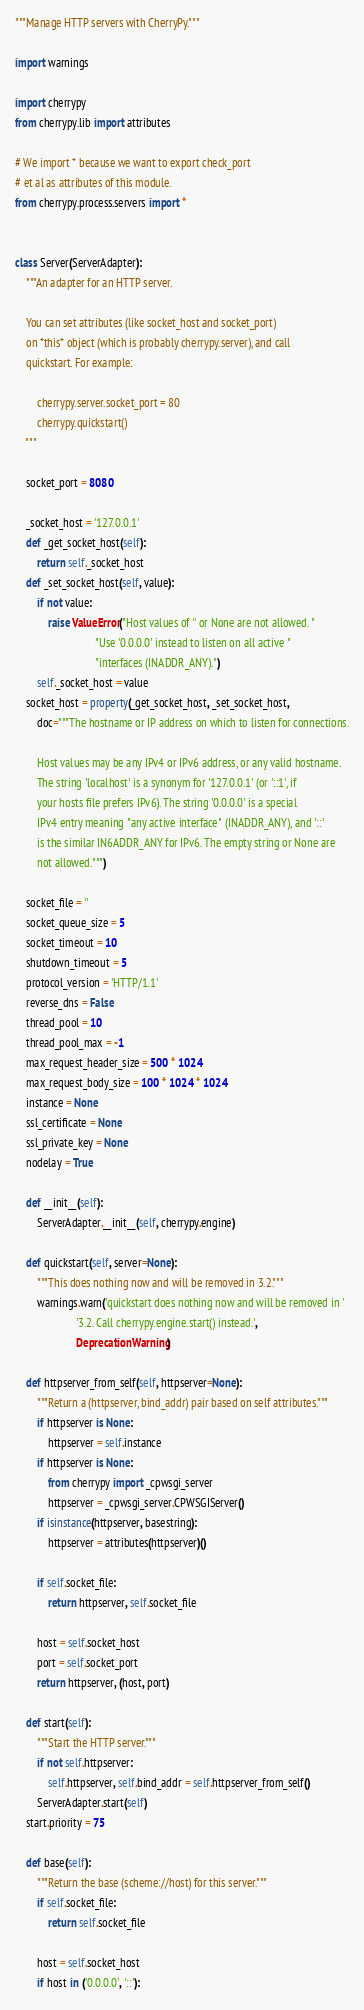<code> <loc_0><loc_0><loc_500><loc_500><_Python_>"""Manage HTTP servers with CherryPy."""

import warnings

import cherrypy
from cherrypy.lib import attributes

# We import * because we want to export check_port
# et al as attributes of this module.
from cherrypy.process.servers import *


class Server(ServerAdapter):
    """An adapter for an HTTP server.
    
    You can set attributes (like socket_host and socket_port)
    on *this* object (which is probably cherrypy.server), and call
    quickstart. For example:
    
        cherrypy.server.socket_port = 80
        cherrypy.quickstart()
    """
    
    socket_port = 8080
    
    _socket_host = '127.0.0.1'
    def _get_socket_host(self):
        return self._socket_host
    def _set_socket_host(self, value):
        if not value:
            raise ValueError("Host values of '' or None are not allowed. "
                             "Use '0.0.0.0' instead to listen on all active "
                             "interfaces (INADDR_ANY).")
        self._socket_host = value
    socket_host = property(_get_socket_host, _set_socket_host,
        doc="""The hostname or IP address on which to listen for connections.
        
        Host values may be any IPv4 or IPv6 address, or any valid hostname.
        The string 'localhost' is a synonym for '127.0.0.1' (or '::1', if
        your hosts file prefers IPv6). The string '0.0.0.0' is a special
        IPv4 entry meaning "any active interface" (INADDR_ANY), and '::'
        is the similar IN6ADDR_ANY for IPv6. The empty string or None are
        not allowed.""")
    
    socket_file = ''
    socket_queue_size = 5
    socket_timeout = 10
    shutdown_timeout = 5
    protocol_version = 'HTTP/1.1'
    reverse_dns = False
    thread_pool = 10
    thread_pool_max = -1
    max_request_header_size = 500 * 1024
    max_request_body_size = 100 * 1024 * 1024
    instance = None
    ssl_certificate = None
    ssl_private_key = None
    nodelay = True
    
    def __init__(self):
        ServerAdapter.__init__(self, cherrypy.engine)
    
    def quickstart(self, server=None):
        """This does nothing now and will be removed in 3.2."""
        warnings.warn('quickstart does nothing now and will be removed in '
                      '3.2. Call cherrypy.engine.start() instead.',
                      DeprecationWarning)
    
    def httpserver_from_self(self, httpserver=None):
        """Return a (httpserver, bind_addr) pair based on self attributes."""
        if httpserver is None:
            httpserver = self.instance
        if httpserver is None:
            from cherrypy import _cpwsgi_server
            httpserver = _cpwsgi_server.CPWSGIServer()
        if isinstance(httpserver, basestring):
            httpserver = attributes(httpserver)()
        
        if self.socket_file:
            return httpserver, self.socket_file
        
        host = self.socket_host
        port = self.socket_port
        return httpserver, (host, port)
    
    def start(self):
        """Start the HTTP server."""
        if not self.httpserver:
            self.httpserver, self.bind_addr = self.httpserver_from_self()
        ServerAdapter.start(self)
    start.priority = 75
    
    def base(self):
        """Return the base (scheme://host) for this server."""
        if self.socket_file:
            return self.socket_file
        
        host = self.socket_host
        if host in ('0.0.0.0', '::'):</code> 